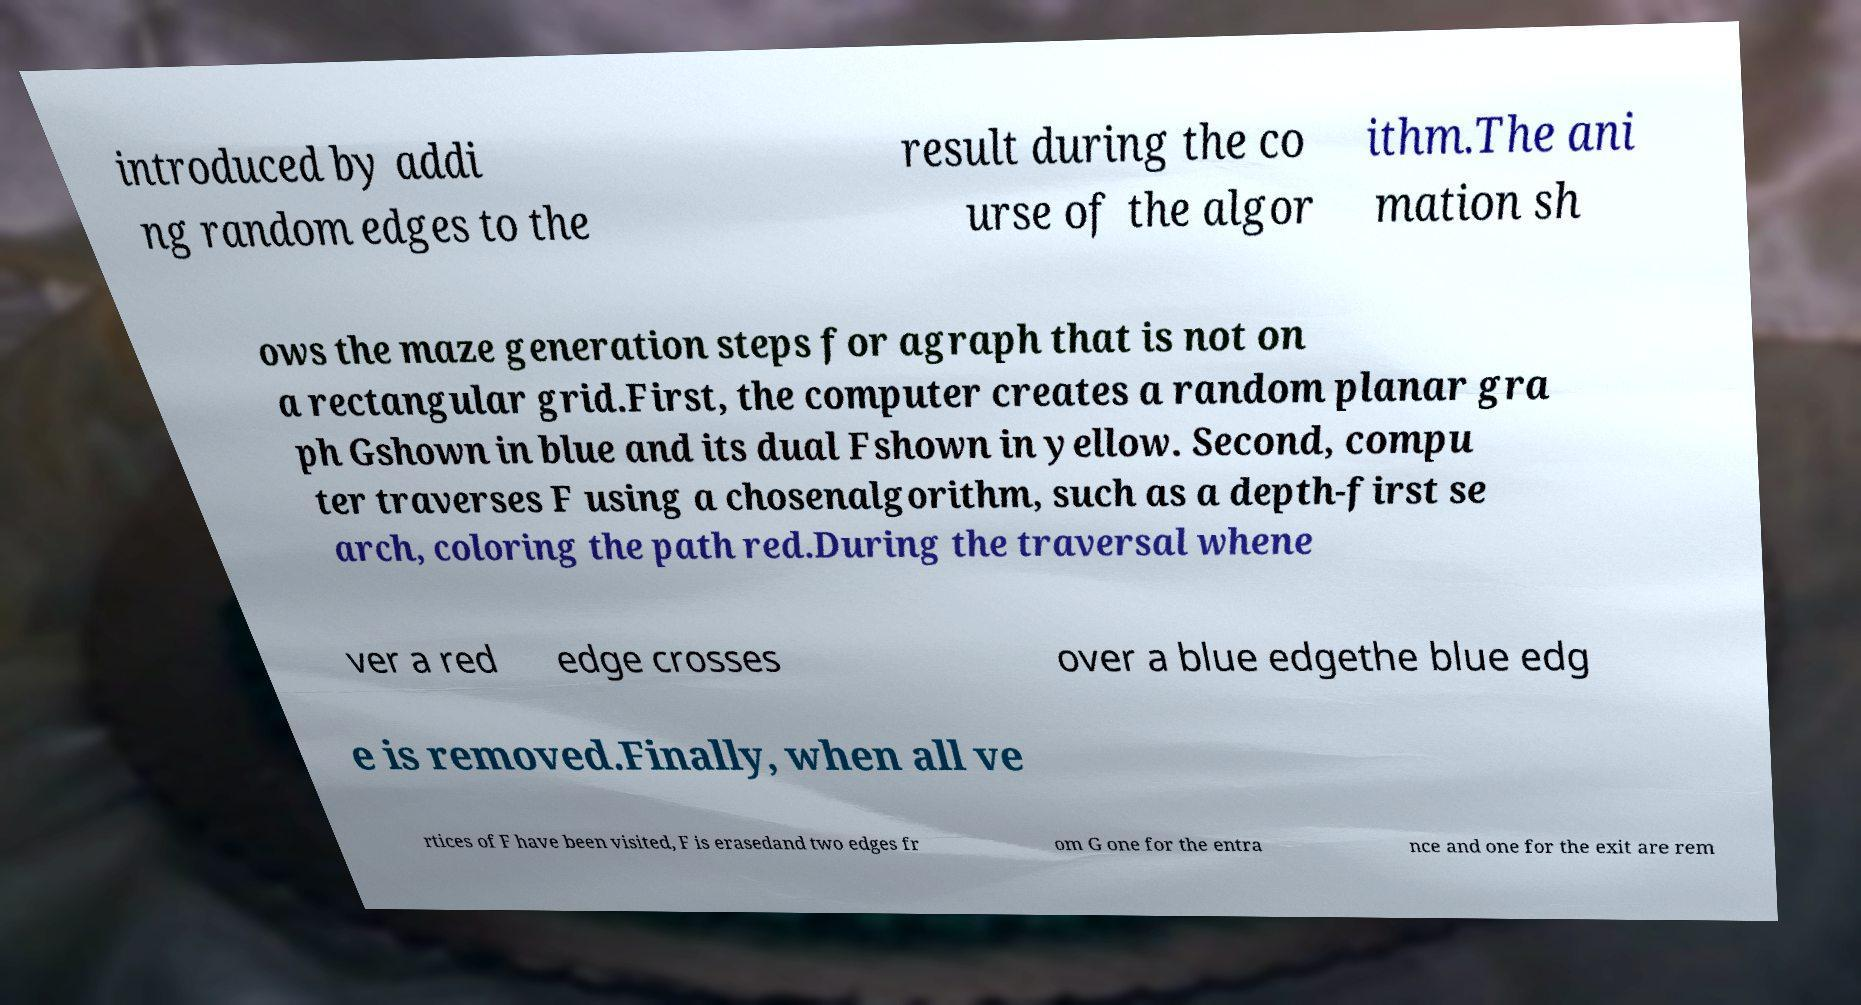Can you accurately transcribe the text from the provided image for me? introduced by addi ng random edges to the result during the co urse of the algor ithm.The ani mation sh ows the maze generation steps for agraph that is not on a rectangular grid.First, the computer creates a random planar gra ph Gshown in blue and its dual Fshown in yellow. Second, compu ter traverses F using a chosenalgorithm, such as a depth-first se arch, coloring the path red.During the traversal whene ver a red edge crosses over a blue edgethe blue edg e is removed.Finally, when all ve rtices of F have been visited, F is erasedand two edges fr om G one for the entra nce and one for the exit are rem 